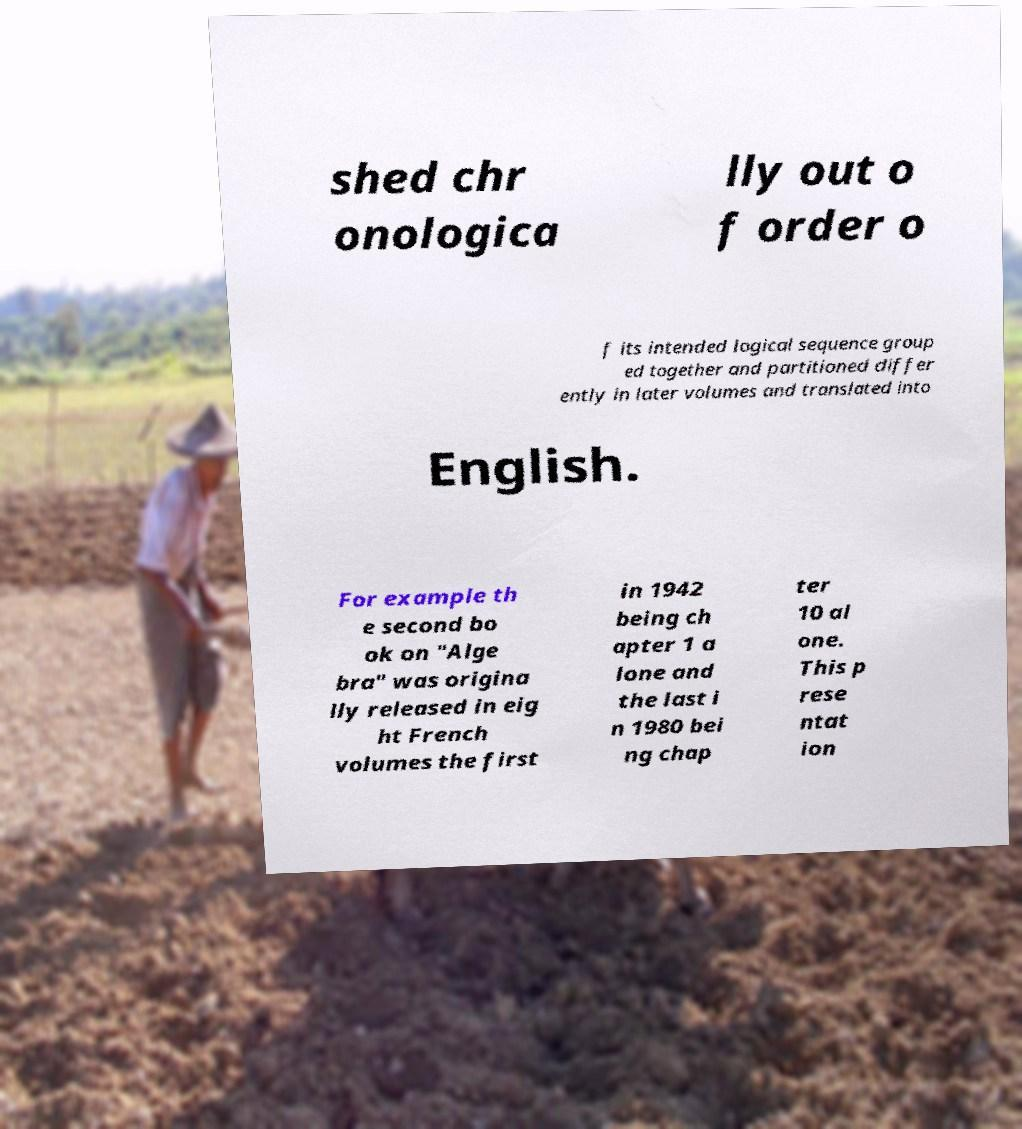What messages or text are displayed in this image? I need them in a readable, typed format. shed chr onologica lly out o f order o f its intended logical sequence group ed together and partitioned differ ently in later volumes and translated into English. For example th e second bo ok on "Alge bra" was origina lly released in eig ht French volumes the first in 1942 being ch apter 1 a lone and the last i n 1980 bei ng chap ter 10 al one. This p rese ntat ion 